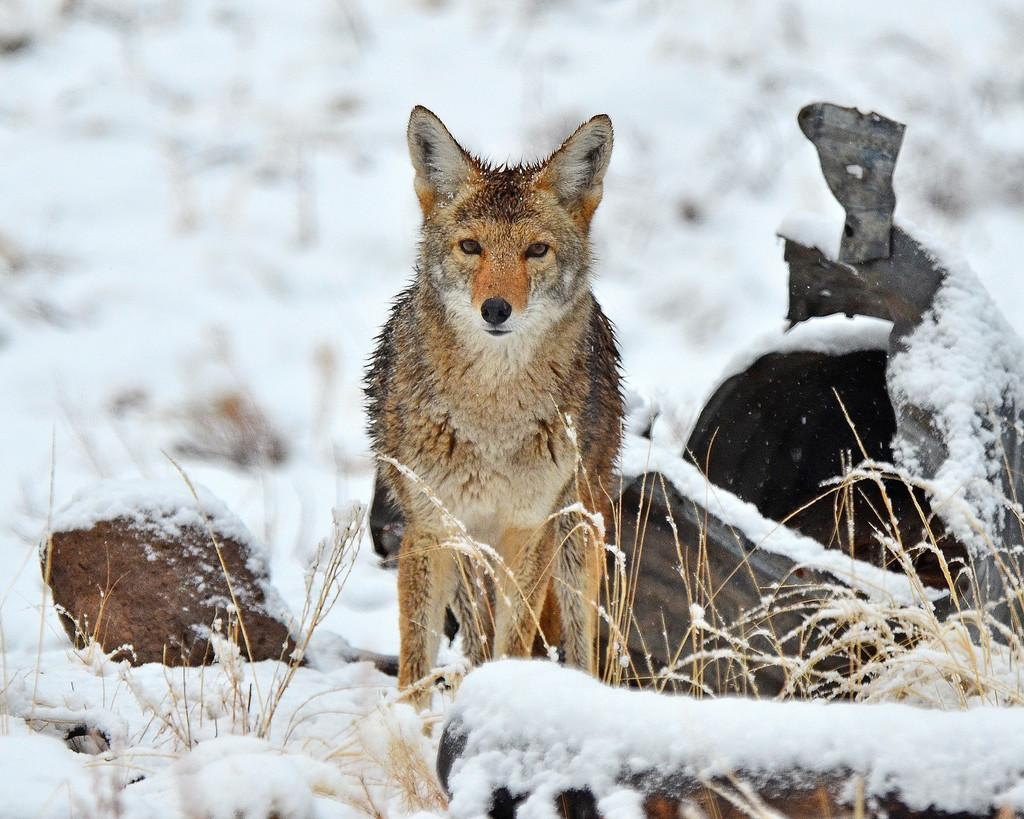What type of animal is present in the image? There is a dog in the image. What material are the bricks made of in the image? The bricks in the image are made of wood. What type of toothpaste is the giraffe using in the image? There is no giraffe or toothpaste present in the image. 